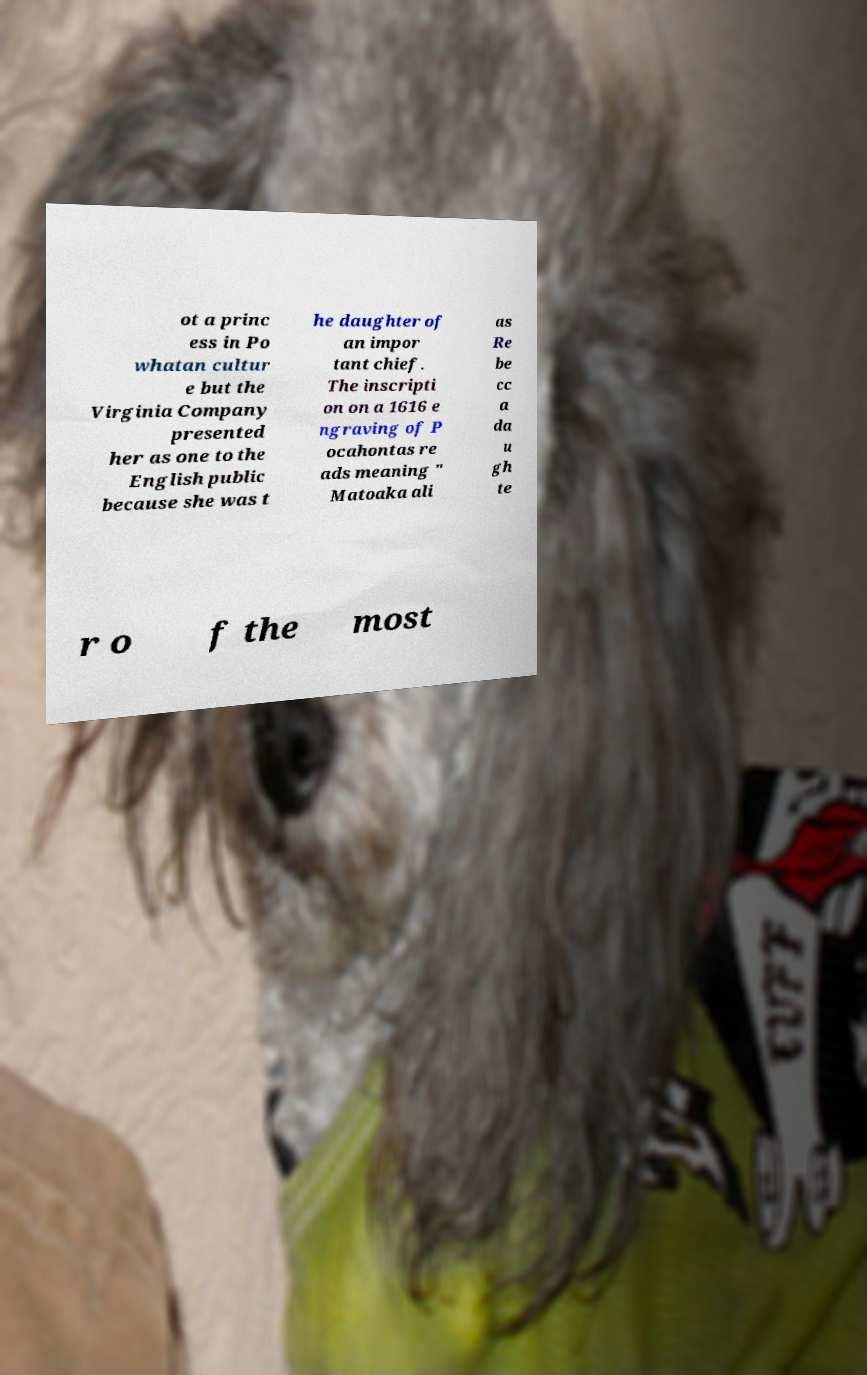There's text embedded in this image that I need extracted. Can you transcribe it verbatim? ot a princ ess in Po whatan cultur e but the Virginia Company presented her as one to the English public because she was t he daughter of an impor tant chief. The inscripti on on a 1616 e ngraving of P ocahontas re ads meaning " Matoaka ali as Re be cc a da u gh te r o f the most 